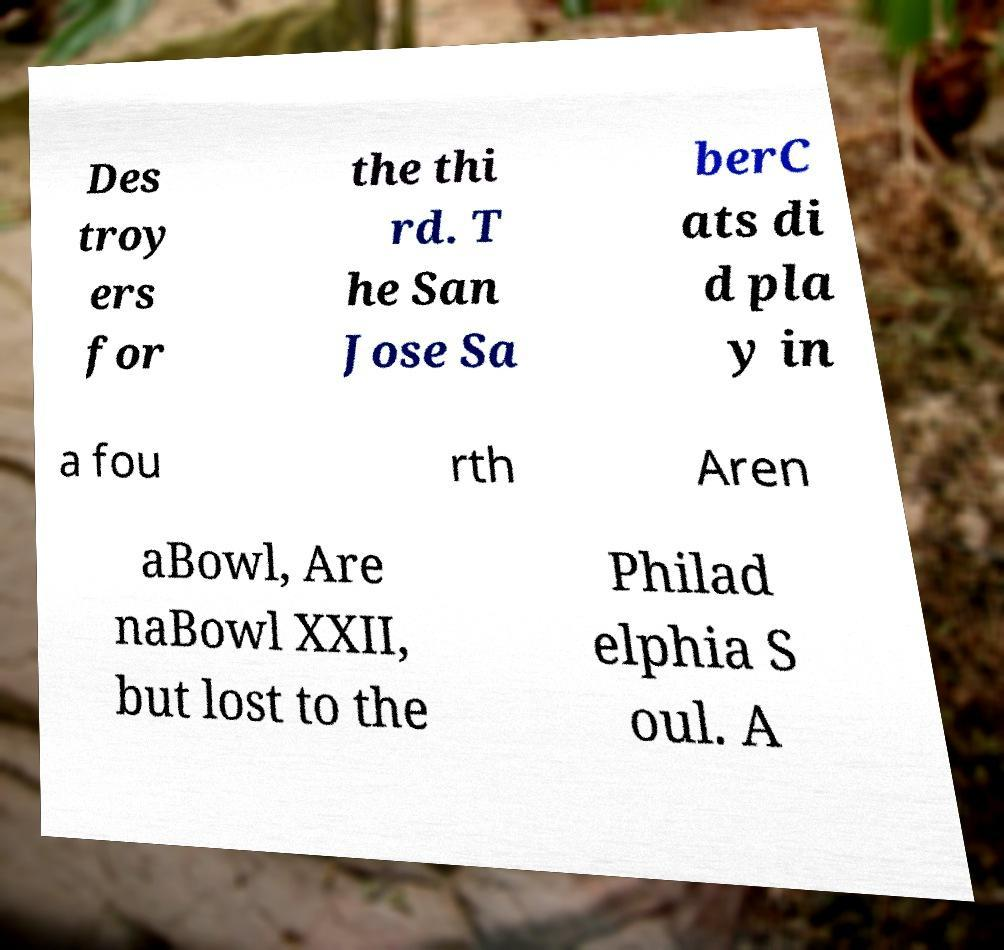Please read and relay the text visible in this image. What does it say? Des troy ers for the thi rd. T he San Jose Sa berC ats di d pla y in a fou rth Aren aBowl, Are naBowl XXII, but lost to the Philad elphia S oul. A 